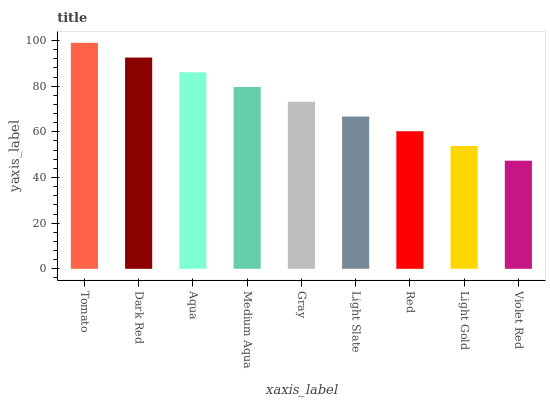Is Violet Red the minimum?
Answer yes or no. Yes. Is Tomato the maximum?
Answer yes or no. Yes. Is Dark Red the minimum?
Answer yes or no. No. Is Dark Red the maximum?
Answer yes or no. No. Is Tomato greater than Dark Red?
Answer yes or no. Yes. Is Dark Red less than Tomato?
Answer yes or no. Yes. Is Dark Red greater than Tomato?
Answer yes or no. No. Is Tomato less than Dark Red?
Answer yes or no. No. Is Gray the high median?
Answer yes or no. Yes. Is Gray the low median?
Answer yes or no. Yes. Is Medium Aqua the high median?
Answer yes or no. No. Is Red the low median?
Answer yes or no. No. 